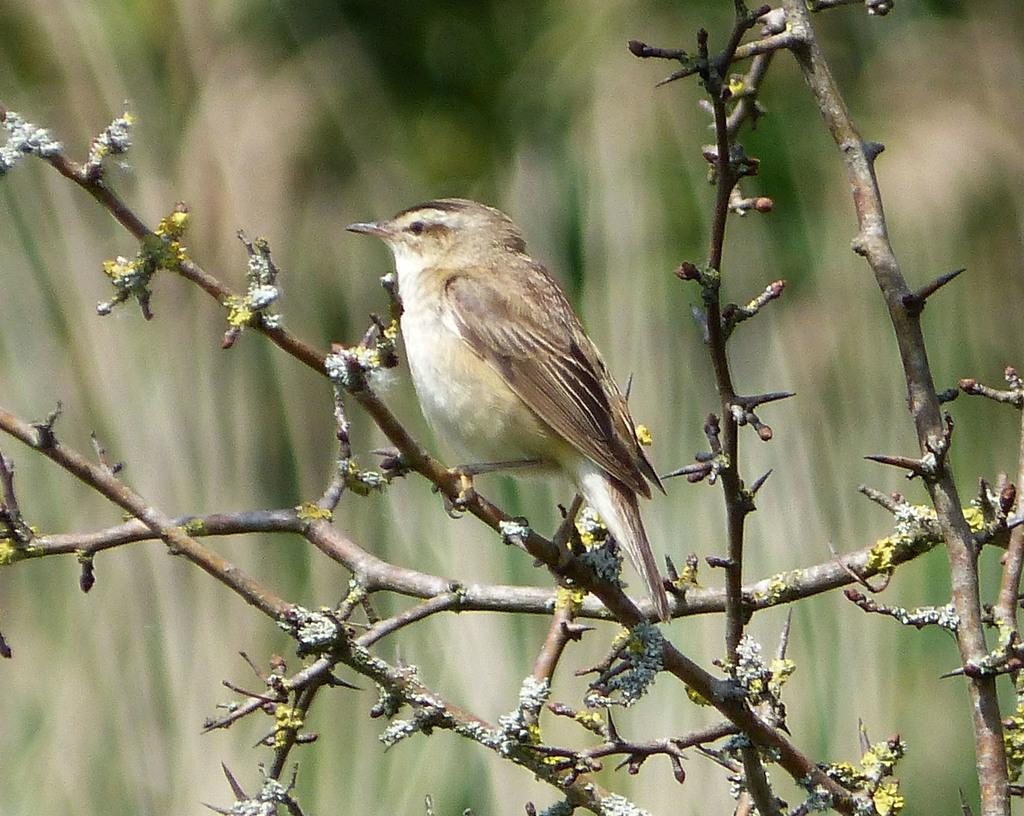What type of animal is in the image? There is a bird in the image. Where is the bird located? The bird is on a stem in the image. Which direction is the bird facing? The bird is facing towards the left side. What is the stem a part of? The stem appears to be part of a plant. How would you describe the background of the image? The background of the image is blurred. What type of yam is placed on the table in the image? There is no yam or table present in the image; it features a bird on a stem. What is the bird's reaction to the surprise in the image? There is no surprise present in the image, and therefore no reaction can be observed from the bird. 